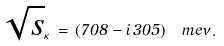<formula> <loc_0><loc_0><loc_500><loc_500>\sqrt { s } _ { \kappa } \, = \, ( 7 0 8 - i \, 3 0 5 ) \, \ m e v \, .</formula> 